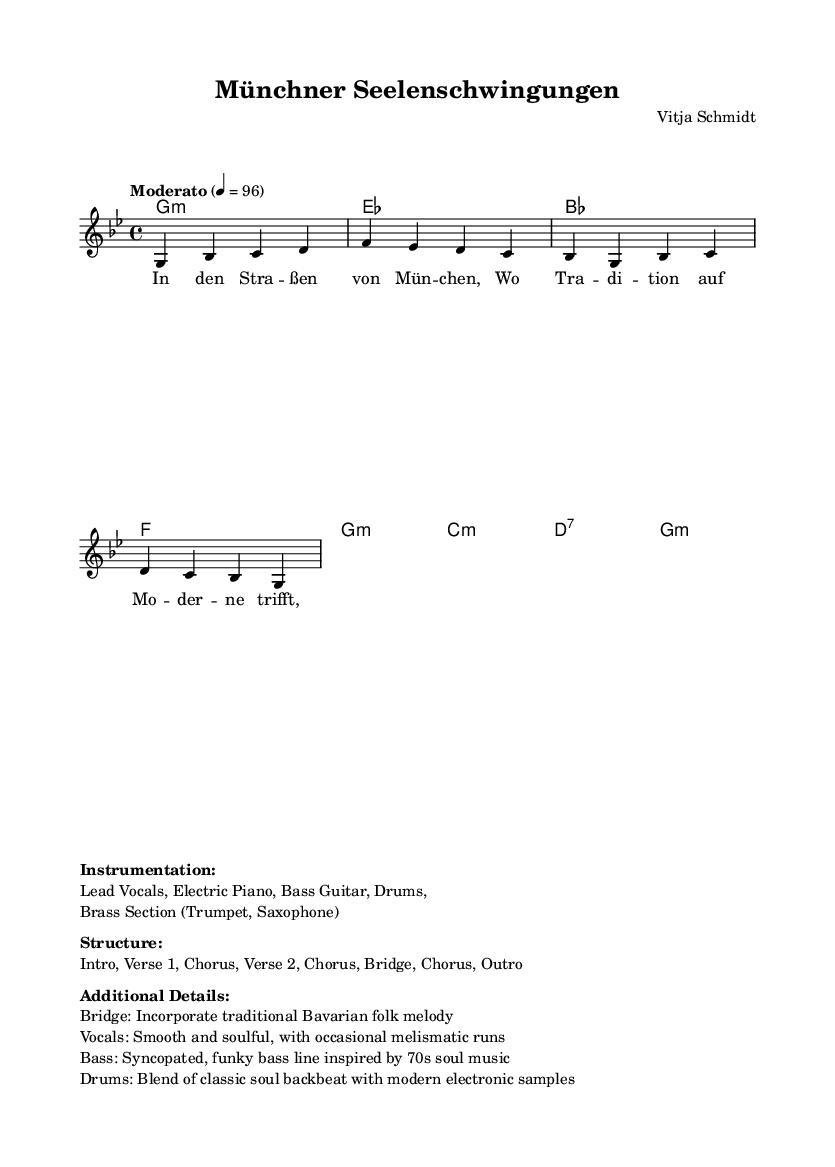What is the key signature of this music? The key signature is indicated at the beginning of the sheet music. In this case, it shows one flat, which corresponds to G minor.
Answer: G minor What is the time signature of the piece? The time signature is indicated in the music notation, and it is written as 4/4, which means there are four beats in each measure, and each beat is a quarter note.
Answer: 4/4 What is the tempo marking? The tempo is indicated in the score with a text marking. Here it says "Moderato" followed by a bpm marking of 96. This suggests a moderately paced tempo at 96 beats per minute.
Answer: Moderato, 96 How many measures are in the entire score? By counting the number of distinct measures in the score, we can see that there are a total of 16 measures presented in the music.
Answer: 16 What traditional element is incorporated in the bridge? The additional details provided indicate that a traditional Bavarian folk melody is incorporated in the bridge section. This suggests a blend of the folk style with modern influences.
Answer: Traditional Bavarian folk melody What instruments are included in the instrumentation? The instrumentation section outlines all the instruments used in this piece. It lists Lead Vocals, Electric Piano, Bass Guitar, Drums, and a Brass Section consisting of Trumpet and Saxophone.
Answer: Lead Vocals, Electric Piano, Bass Guitar, Drums, Brass Section What style does the bass line in this piece draw inspiration from? According to the additional details, the bass line is syncopated and draws inspiration from 70s soul music, indicating a specific influence in its rhythm and groove.
Answer: 70s soul music 